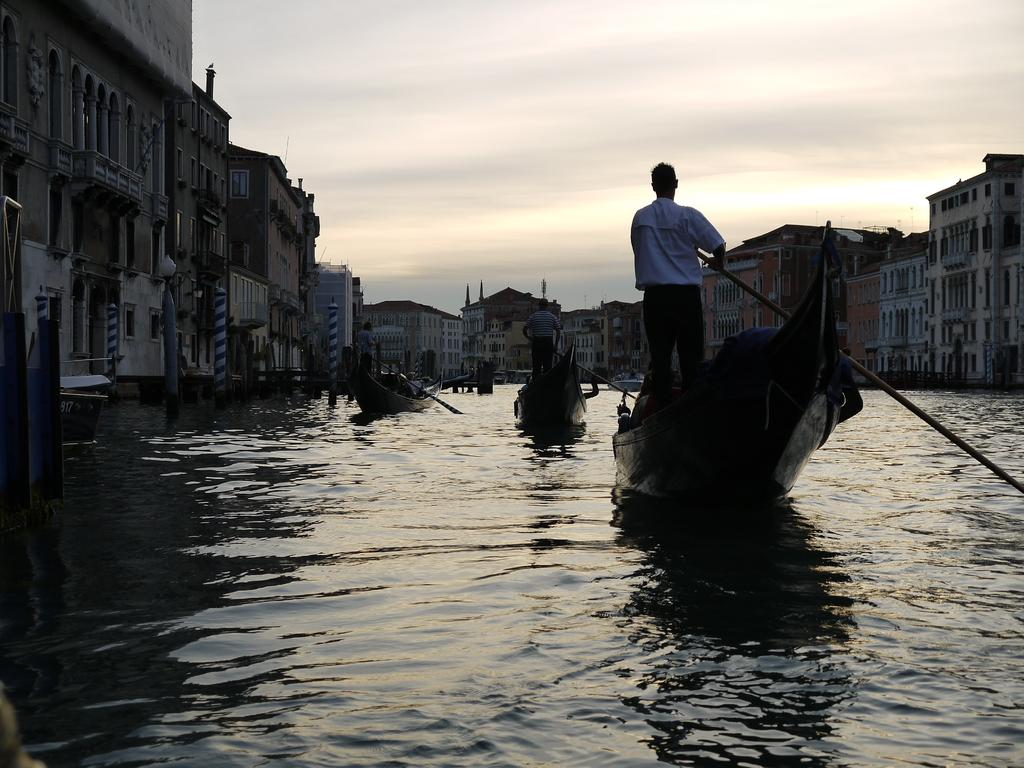What are the people on the boats doing? The people on the boats are holding paddles. What can be seen in the background of the image? There are buildings and windows visible in the image. What is the purpose of the light pole in the image? The light pole provides illumination in the image. What is the primary feature of the water in the image? The water is visible in the image. What is visible in the sky in the image? The sky is visible in the image. What type of drink is the user holding while playing the guitar in the image? There is no user, drink, or guitar present in the image. In which direction are the people on the boats paddling? The direction in which the people on the boats are paddling cannot be determined from the image. 